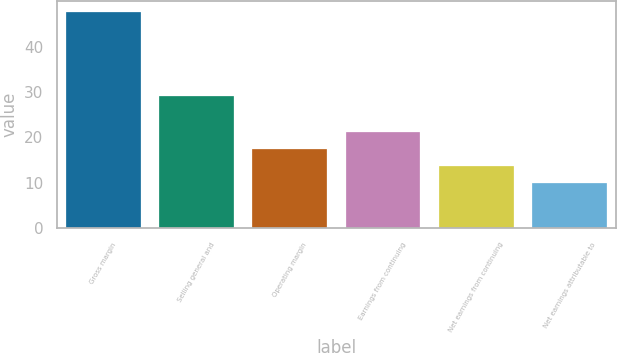Convert chart. <chart><loc_0><loc_0><loc_500><loc_500><bar_chart><fcel>Gross margin<fcel>Selling general and<fcel>Operating margin<fcel>Earnings from continuing<fcel>Net earnings from continuing<fcel>Net earnings attributable to<nl><fcel>47.6<fcel>29.1<fcel>17.44<fcel>21.21<fcel>13.67<fcel>9.9<nl></chart> 